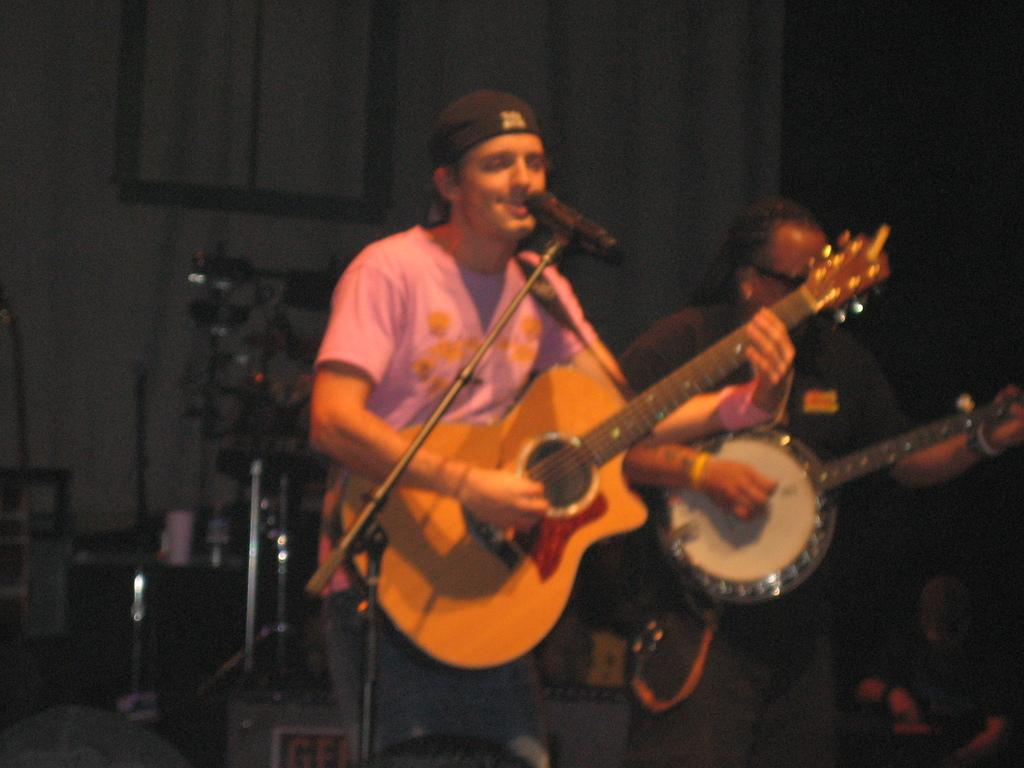How many people are in the image? There are two persons in the image. What are the persons doing in the image? The persons are standing and playing musical instruments. Can you describe any equipment visible in the image? Yes, there are speakers at the back of the image and microphones in the front of the image. How many pigs are sitting on the table in the image? There are no pigs or tables present in the image. What scientific theory is being discussed in the image? There is no discussion or mention of any scientific theory in the image. 